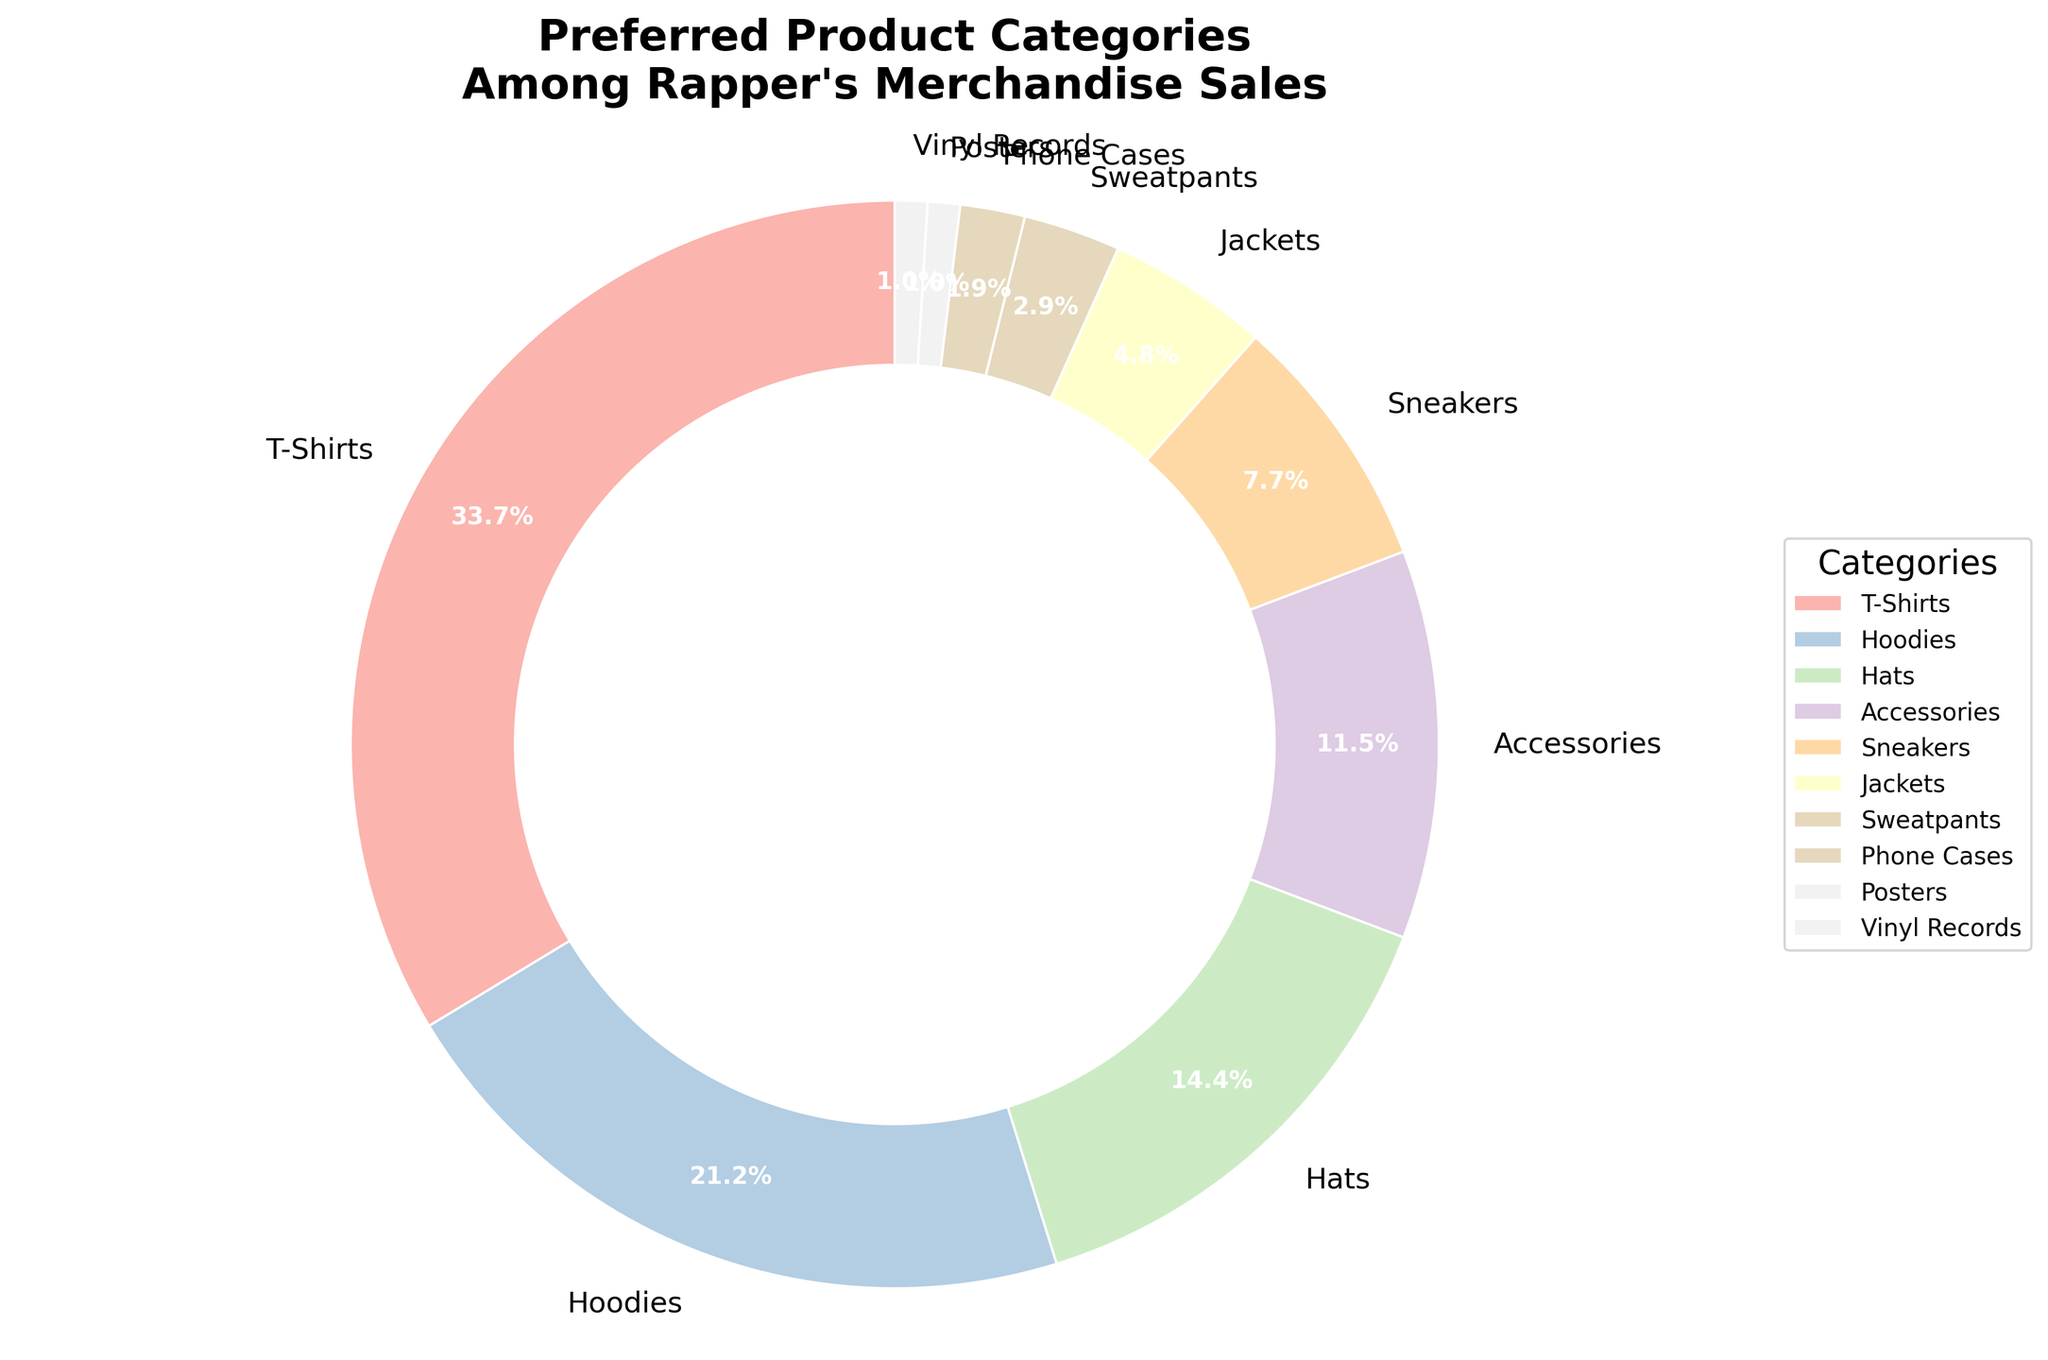What's the most preferred product category among the rapper's merchandise sales? By examining the pie chart, we can see that T-Shirts occupy the largest portion of the chart at 35%, making them the most preferred product category.
Answer: T-Shirts Which category has the smallest percentage of sales, and what is that percentage? Observing the pie chart, the smallest portion is shared by Posters and Vinyl Records, each with 1%.
Answer: Posters and Vinyl Records, 1% What is the combined percentage of Hoodies and Hats sales? Hoodies have a sales percentage of 22%, and Hats have 15%. Summing these up, 22% + 15% = 37%.
Answer: 37% How much more popular are T-Shirts compared to Sneakers? T-Shirts have 35% of sales, while Sneakers have 8%. The difference is 35% - 8% = 27%.
Answer: 27% Are Jackets more popular than Phone Cases? By looking at the pie chart segments, we see that Jackets have 5% of sales, while Phone Cases have 2%. Since 5% > 2%, Jackets are more popular than Phone Cases.
Answer: Yes Which products make up more than 10% of the sales? Analyzing the pie chart, the segments that are larger than 10% are T-Shirts (35%), Hoodies (22%), Hats (15%), and Accessories (12%).
Answer: T-Shirts, Hoodies, Hats, Accessories How does the percentage of Hoodies compare to that of Accessories and Hats combined? Hoodies make up 22% of sales. Accessories are 12% and Hats are 15%. The combined percentage of Accessories and Hats is 12% + 15% = 27%. Since 27% > 22%, Accessories and Hats have a higher combined percentage than Hoodies.
Answer: Accessories and Hats combined are more popular What is the total percentage of all merchandise categories that are below 5%? Adding the percentages of items below 5%: Jackets (5%), Sweatpants (3%), Phone Cases (2%), Posters (1%), and Vinyl Records (1%). The total is 5% + 3% + 2% + 1% + 1% = 12%.
Answer: 12% Which type of apparel (T-Shirts, Hoodies, Jackets, Sweatpants) has the lowest percentage of sales? Comparing the segments for T-Shirts (35%), Hoodies (22%), Jackets (5%), and Sweatpants (3%), we see that Sweatpants have the lowest percentage.
Answer: Sweatpants 